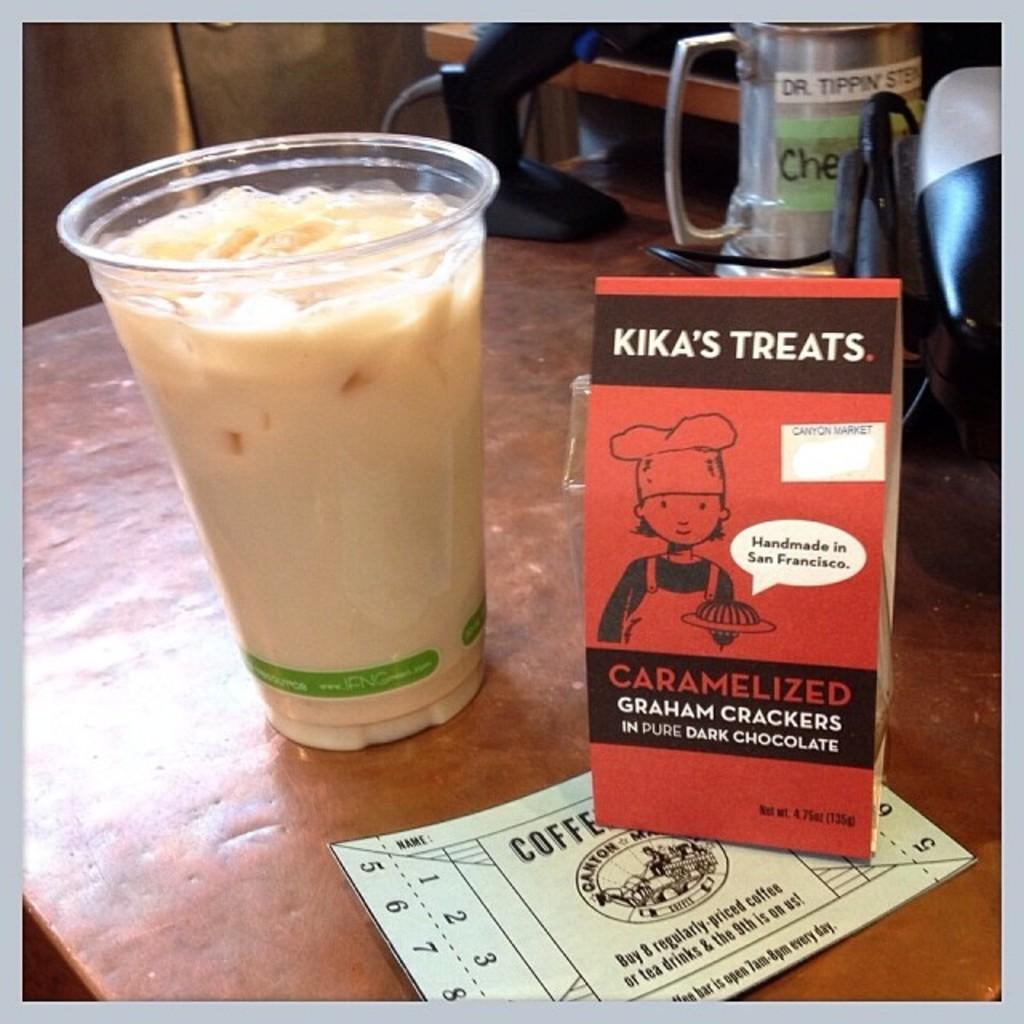What is located on the surface in the foreground area? There is a glass, a coffee paper, and a treats card on the surface in the foreground area. What type of objects are present in the background area? The details about the objects in the background area are not provided in the facts. Can you describe the objects in the foreground area? Yes, there is a glass, a coffee paper, and a treats card on the surface in the foreground area. What type of goat can be seen wearing a jewel in the image? There is no goat or jewel present in the image. What government policy is being discussed in the image? There is no discussion of government policy in the image. 